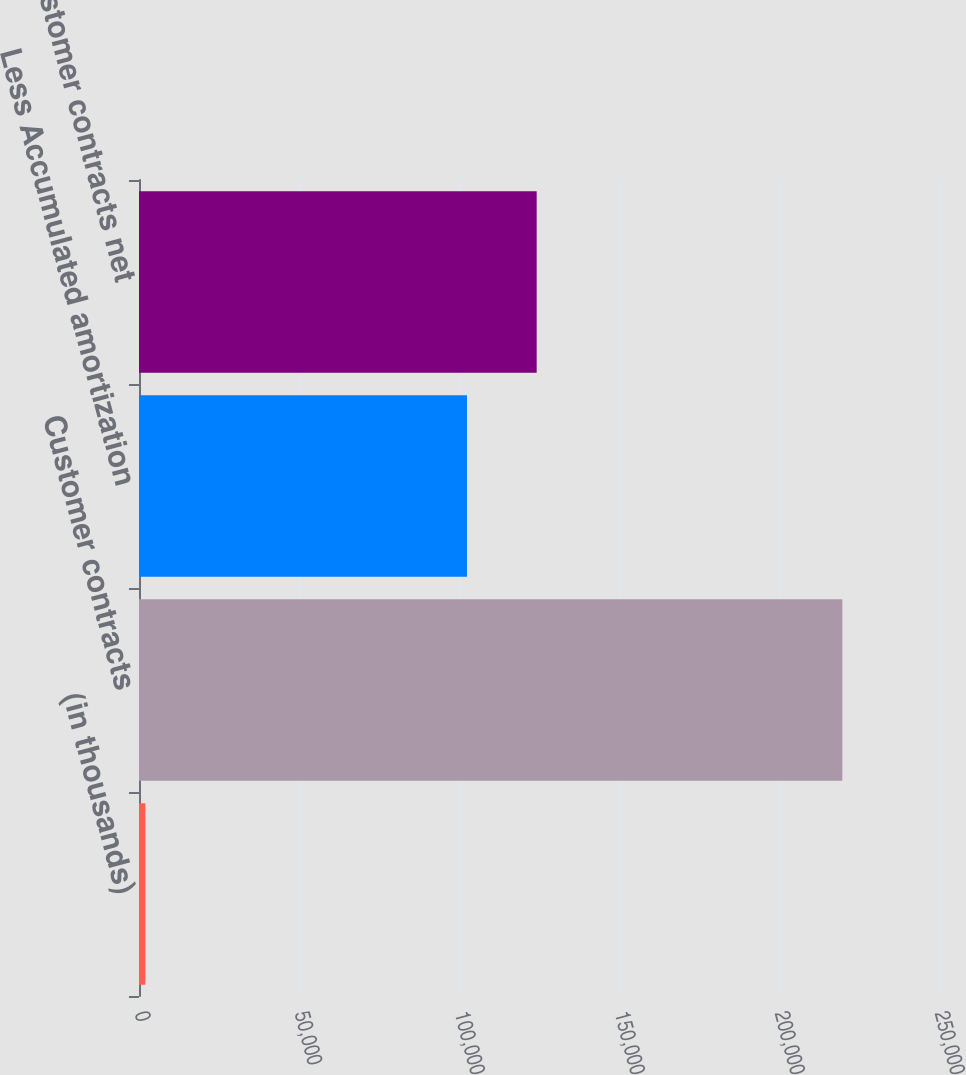Convert chart to OTSL. <chart><loc_0><loc_0><loc_500><loc_500><bar_chart><fcel>(in thousands)<fcel>Customer contracts<fcel>Less Accumulated amortization<fcel>Customer contracts net<nl><fcel>2010<fcel>219787<fcel>102496<fcel>124274<nl></chart> 